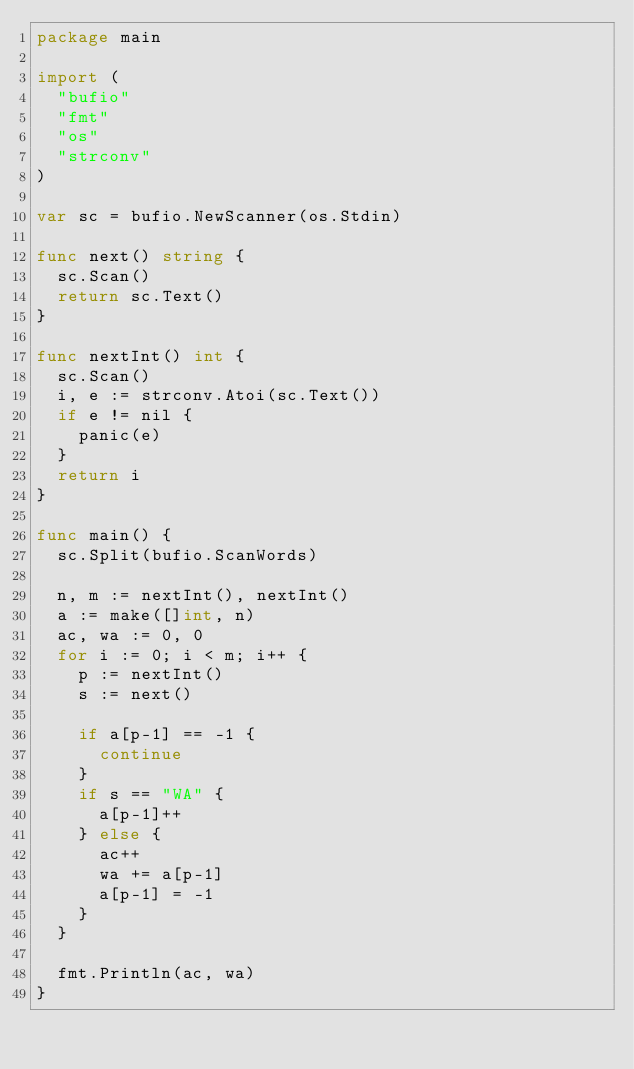Convert code to text. <code><loc_0><loc_0><loc_500><loc_500><_Go_>package main

import (
	"bufio"
	"fmt"
	"os"
	"strconv"
)

var sc = bufio.NewScanner(os.Stdin)

func next() string {
	sc.Scan()
	return sc.Text()
}

func nextInt() int {
	sc.Scan()
	i, e := strconv.Atoi(sc.Text())
	if e != nil {
		panic(e)
	}
	return i
}

func main() {
	sc.Split(bufio.ScanWords)

	n, m := nextInt(), nextInt()
	a := make([]int, n)
	ac, wa := 0, 0
	for i := 0; i < m; i++ {
		p := nextInt()
		s := next()

		if a[p-1] == -1 {
			continue
		}
		if s == "WA" {
			a[p-1]++
		} else {
			ac++
			wa += a[p-1]
			a[p-1] = -1
		}
	}

	fmt.Println(ac, wa)
}</code> 